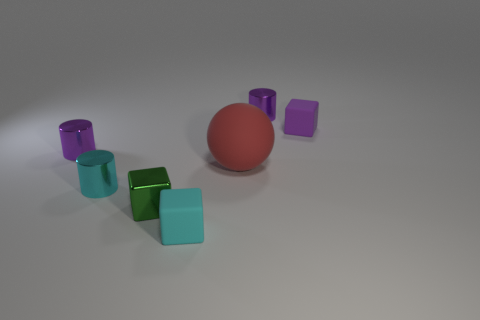Add 3 cyan metal objects. How many objects exist? 10 Subtract all cylinders. How many objects are left? 4 Subtract 0 purple balls. How many objects are left? 7 Subtract all small cyan metal cylinders. Subtract all large rubber cubes. How many objects are left? 6 Add 7 shiny cubes. How many shiny cubes are left? 8 Add 6 tiny gray metallic cubes. How many tiny gray metallic cubes exist? 6 